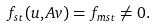Convert formula to latex. <formula><loc_0><loc_0><loc_500><loc_500>f _ { s t } ( u , A v ) = f _ { m s t } \neq 0 .</formula> 